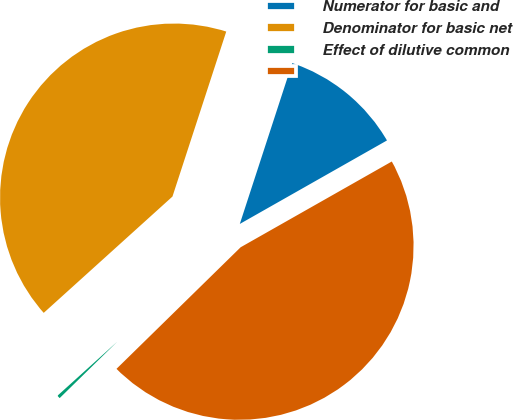Convert chart. <chart><loc_0><loc_0><loc_500><loc_500><pie_chart><fcel>Numerator for basic and<fcel>Denominator for basic net<fcel>Effect of dilutive common<fcel>Unnamed: 3<nl><fcel>11.77%<fcel>41.71%<fcel>0.64%<fcel>45.88%<nl></chart> 